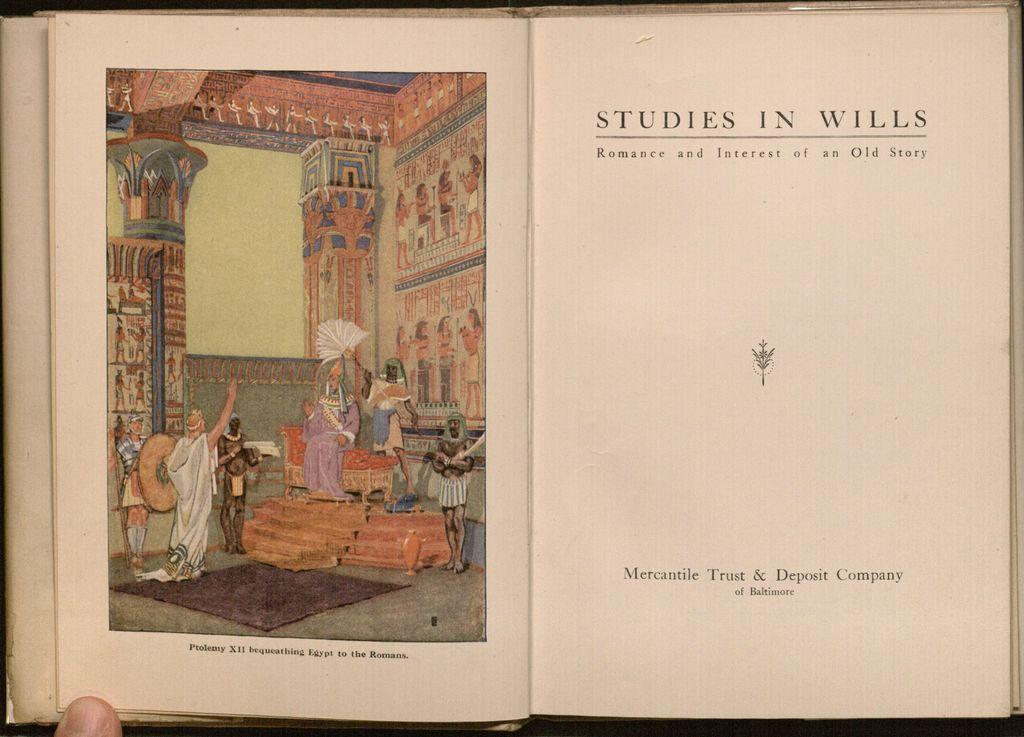<image>
Give a short and clear explanation of the subsequent image. a page in a book labelled studies in wills 